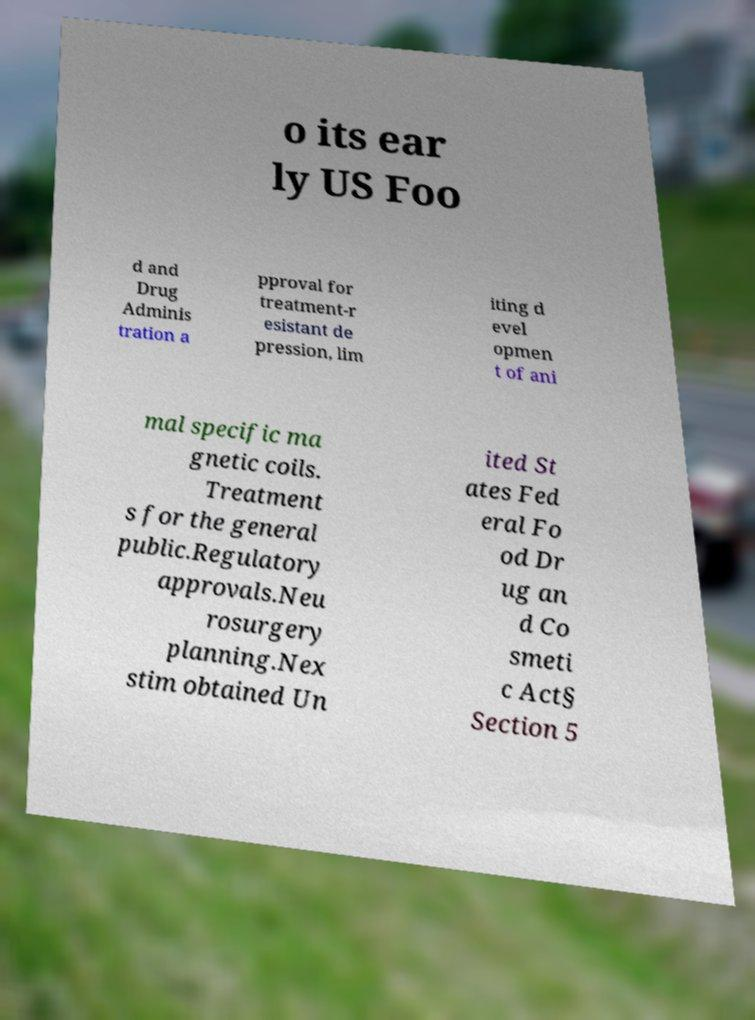Can you accurately transcribe the text from the provided image for me? o its ear ly US Foo d and Drug Adminis tration a pproval for treatment-r esistant de pression, lim iting d evel opmen t of ani mal specific ma gnetic coils. Treatment s for the general public.Regulatory approvals.Neu rosurgery planning.Nex stim obtained Un ited St ates Fed eral Fo od Dr ug an d Co smeti c Act§ Section 5 